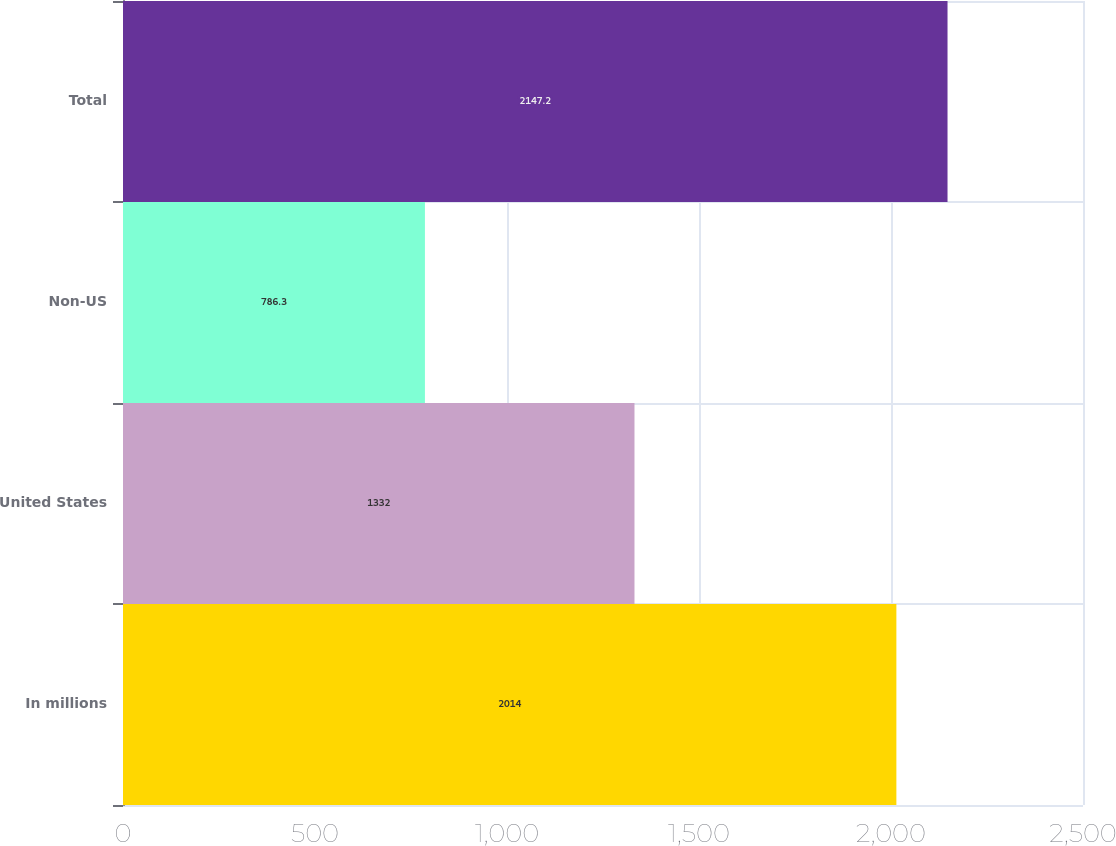Convert chart to OTSL. <chart><loc_0><loc_0><loc_500><loc_500><bar_chart><fcel>In millions<fcel>United States<fcel>Non-US<fcel>Total<nl><fcel>2014<fcel>1332<fcel>786.3<fcel>2147.2<nl></chart> 